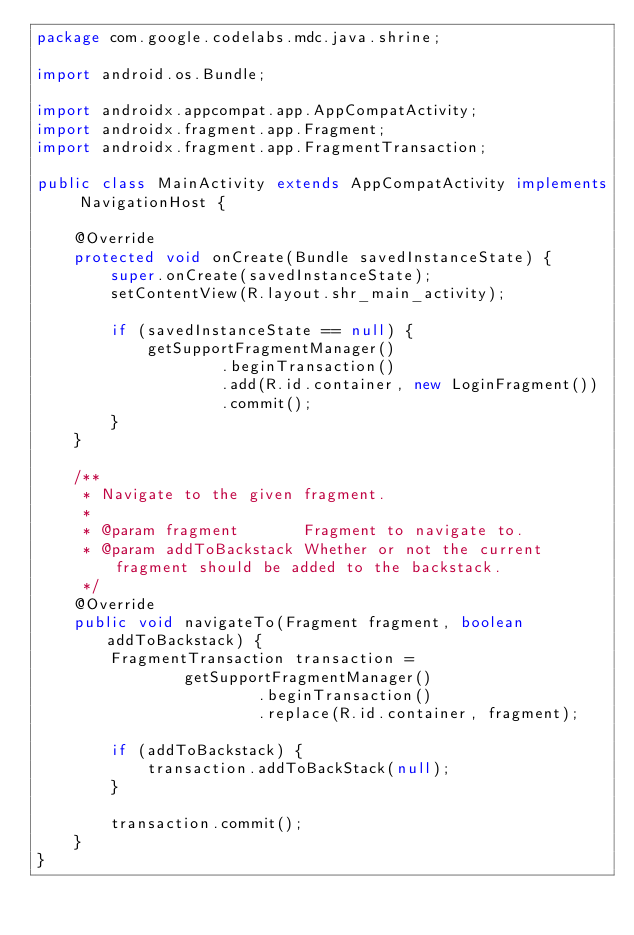<code> <loc_0><loc_0><loc_500><loc_500><_Java_>package com.google.codelabs.mdc.java.shrine;

import android.os.Bundle;

import androidx.appcompat.app.AppCompatActivity;
import androidx.fragment.app.Fragment;
import androidx.fragment.app.FragmentTransaction;

public class MainActivity extends AppCompatActivity implements NavigationHost {

    @Override
    protected void onCreate(Bundle savedInstanceState) {
        super.onCreate(savedInstanceState);
        setContentView(R.layout.shr_main_activity);

        if (savedInstanceState == null) {
            getSupportFragmentManager()
                    .beginTransaction()
                    .add(R.id.container, new LoginFragment())
                    .commit();
        }
    }

    /**
     * Navigate to the given fragment.
     *
     * @param fragment       Fragment to navigate to.
     * @param addToBackstack Whether or not the current fragment should be added to the backstack.
     */
    @Override
    public void navigateTo(Fragment fragment, boolean addToBackstack) {
        FragmentTransaction transaction =
                getSupportFragmentManager()
                        .beginTransaction()
                        .replace(R.id.container, fragment);

        if (addToBackstack) {
            transaction.addToBackStack(null);
        }

        transaction.commit();
    }
}
</code> 